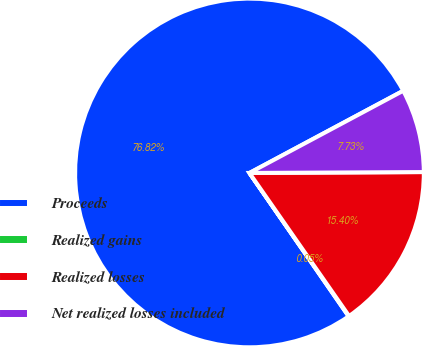Convert chart to OTSL. <chart><loc_0><loc_0><loc_500><loc_500><pie_chart><fcel>Proceeds<fcel>Realized gains<fcel>Realized losses<fcel>Net realized losses included<nl><fcel>76.82%<fcel>0.05%<fcel>15.4%<fcel>7.73%<nl></chart> 